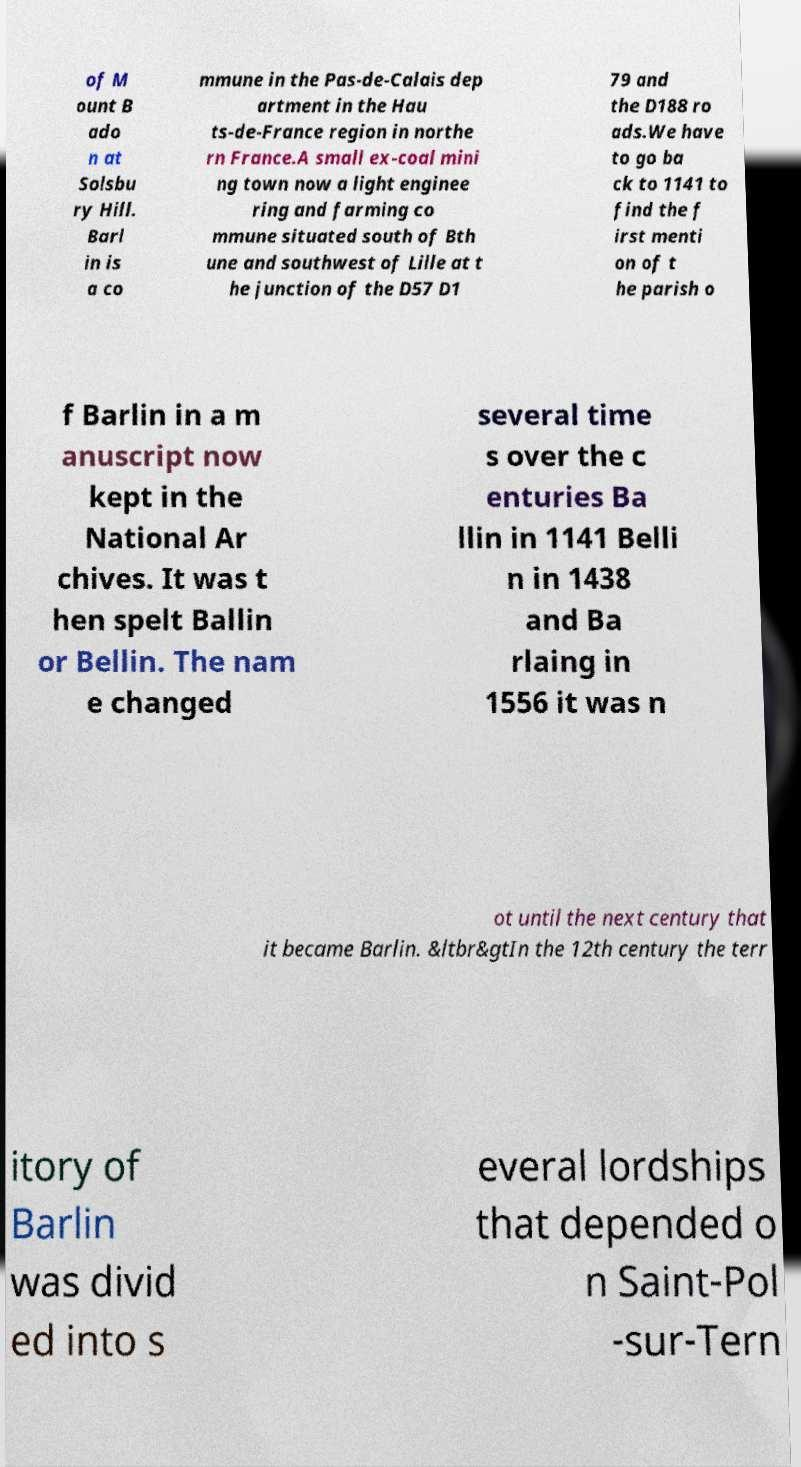I need the written content from this picture converted into text. Can you do that? of M ount B ado n at Solsbu ry Hill. Barl in is a co mmune in the Pas-de-Calais dep artment in the Hau ts-de-France region in northe rn France.A small ex-coal mini ng town now a light enginee ring and farming co mmune situated south of Bth une and southwest of Lille at t he junction of the D57 D1 79 and the D188 ro ads.We have to go ba ck to 1141 to find the f irst menti on of t he parish o f Barlin in a m anuscript now kept in the National Ar chives. It was t hen spelt Ballin or Bellin. The nam e changed several time s over the c enturies Ba llin in 1141 Belli n in 1438 and Ba rlaing in 1556 it was n ot until the next century that it became Barlin. &ltbr&gtIn the 12th century the terr itory of Barlin was divid ed into s everal lordships that depended o n Saint-Pol -sur-Tern 